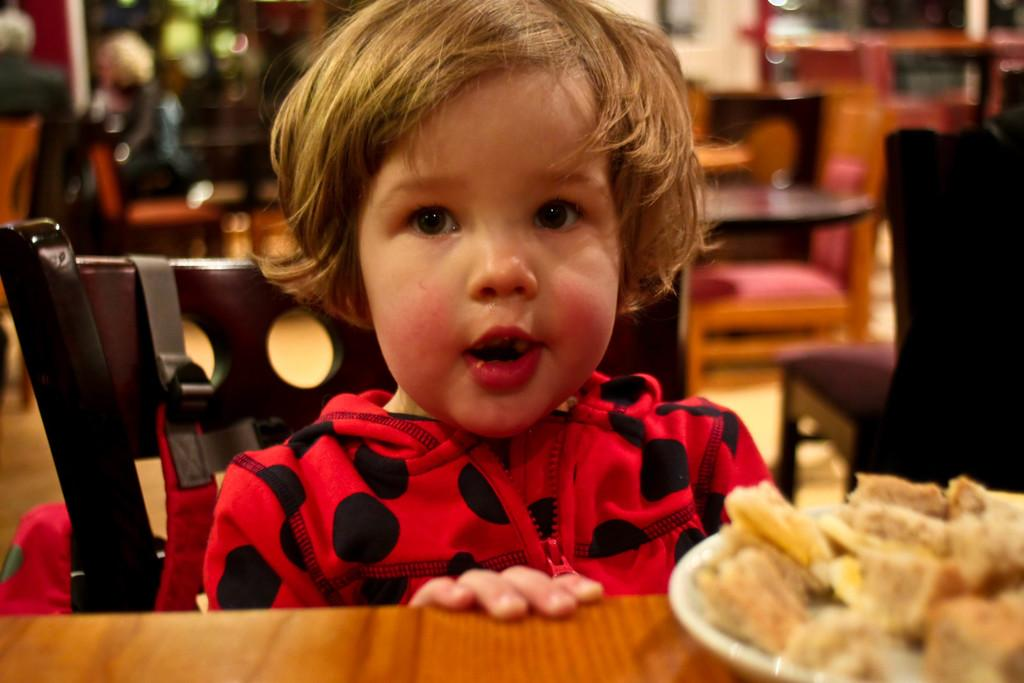Who is the main subject in the image? There is a girl in the image. What is the girl doing in the image? The girl is sitting. What is placed in front of the girl? There is a plate with food items in front of the girl. What type of dinosaurs can be seen playing with the girl in the image? There are no dinosaurs present in the image; it features a girl sitting with a plate of food items in front of her. What letters are being spelled out by the rabbit in the image? There is no rabbit present in the image, so no letters can be spelled out by a rabbit. 